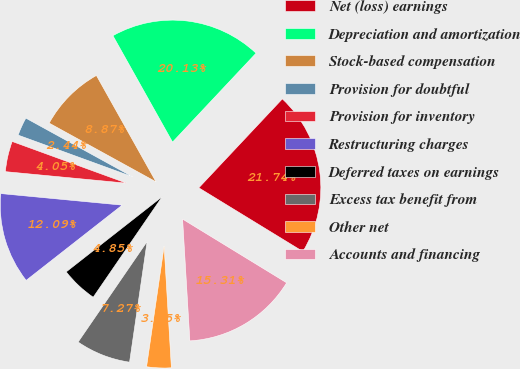Convert chart. <chart><loc_0><loc_0><loc_500><loc_500><pie_chart><fcel>Net (loss) earnings<fcel>Depreciation and amortization<fcel>Stock-based compensation<fcel>Provision for doubtful<fcel>Provision for inventory<fcel>Restructuring charges<fcel>Deferred taxes on earnings<fcel>Excess tax benefit from<fcel>Other net<fcel>Accounts and financing<nl><fcel>21.74%<fcel>20.13%<fcel>8.87%<fcel>2.44%<fcel>4.05%<fcel>12.09%<fcel>4.85%<fcel>7.27%<fcel>3.25%<fcel>15.31%<nl></chart> 